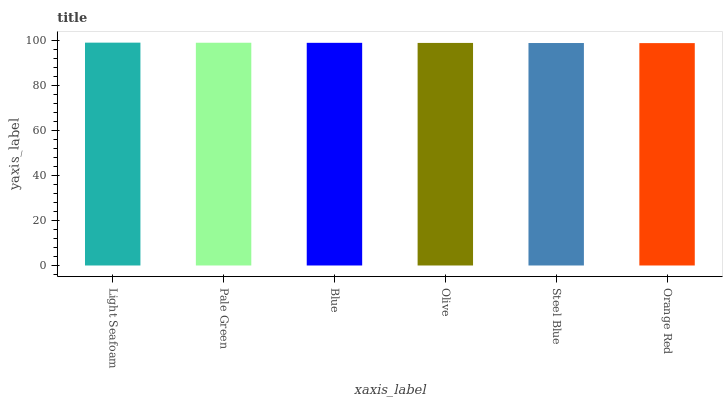Is Orange Red the minimum?
Answer yes or no. Yes. Is Light Seafoam the maximum?
Answer yes or no. Yes. Is Pale Green the minimum?
Answer yes or no. No. Is Pale Green the maximum?
Answer yes or no. No. Is Light Seafoam greater than Pale Green?
Answer yes or no. Yes. Is Pale Green less than Light Seafoam?
Answer yes or no. Yes. Is Pale Green greater than Light Seafoam?
Answer yes or no. No. Is Light Seafoam less than Pale Green?
Answer yes or no. No. Is Blue the high median?
Answer yes or no. Yes. Is Olive the low median?
Answer yes or no. Yes. Is Light Seafoam the high median?
Answer yes or no. No. Is Light Seafoam the low median?
Answer yes or no. No. 